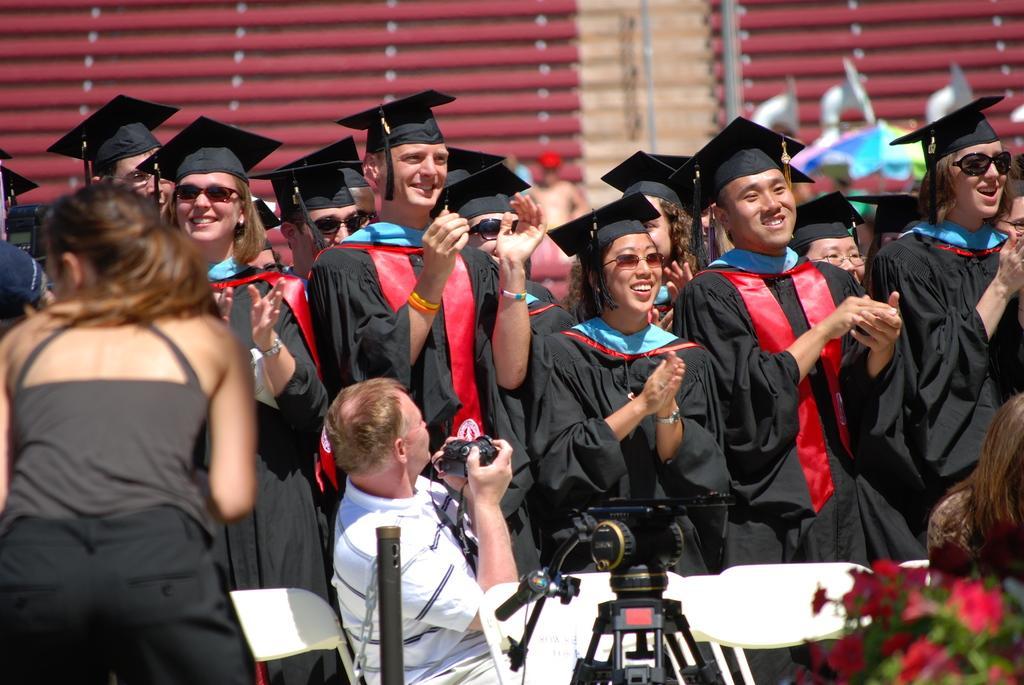How would you summarize this image in a sentence or two? I think this image is taken on a graduation day. Some group of people are wearing black costumes and black hats. In the middle there is a men who is wearing a white t shirt and holding a camera. To the left corner there is a woman, she is wearing grey shirt and black trousers. Towards the right bottom there are some flowers. In the background there is a building. 